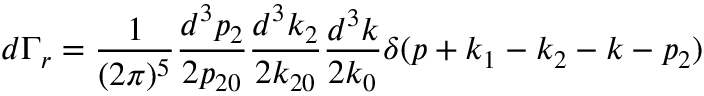Convert formula to latex. <formula><loc_0><loc_0><loc_500><loc_500>d \Gamma _ { r } = \frac { 1 } { ( 2 \pi ) ^ { 5 } } \frac { d ^ { 3 } p _ { 2 } } { 2 p _ { 2 0 } } \frac { d ^ { 3 } k _ { 2 } } { 2 k _ { 2 0 } } \frac { d ^ { 3 } k } { 2 k _ { 0 } } \delta ( p + k _ { 1 } - k _ { 2 } - k - p _ { 2 } )</formula> 